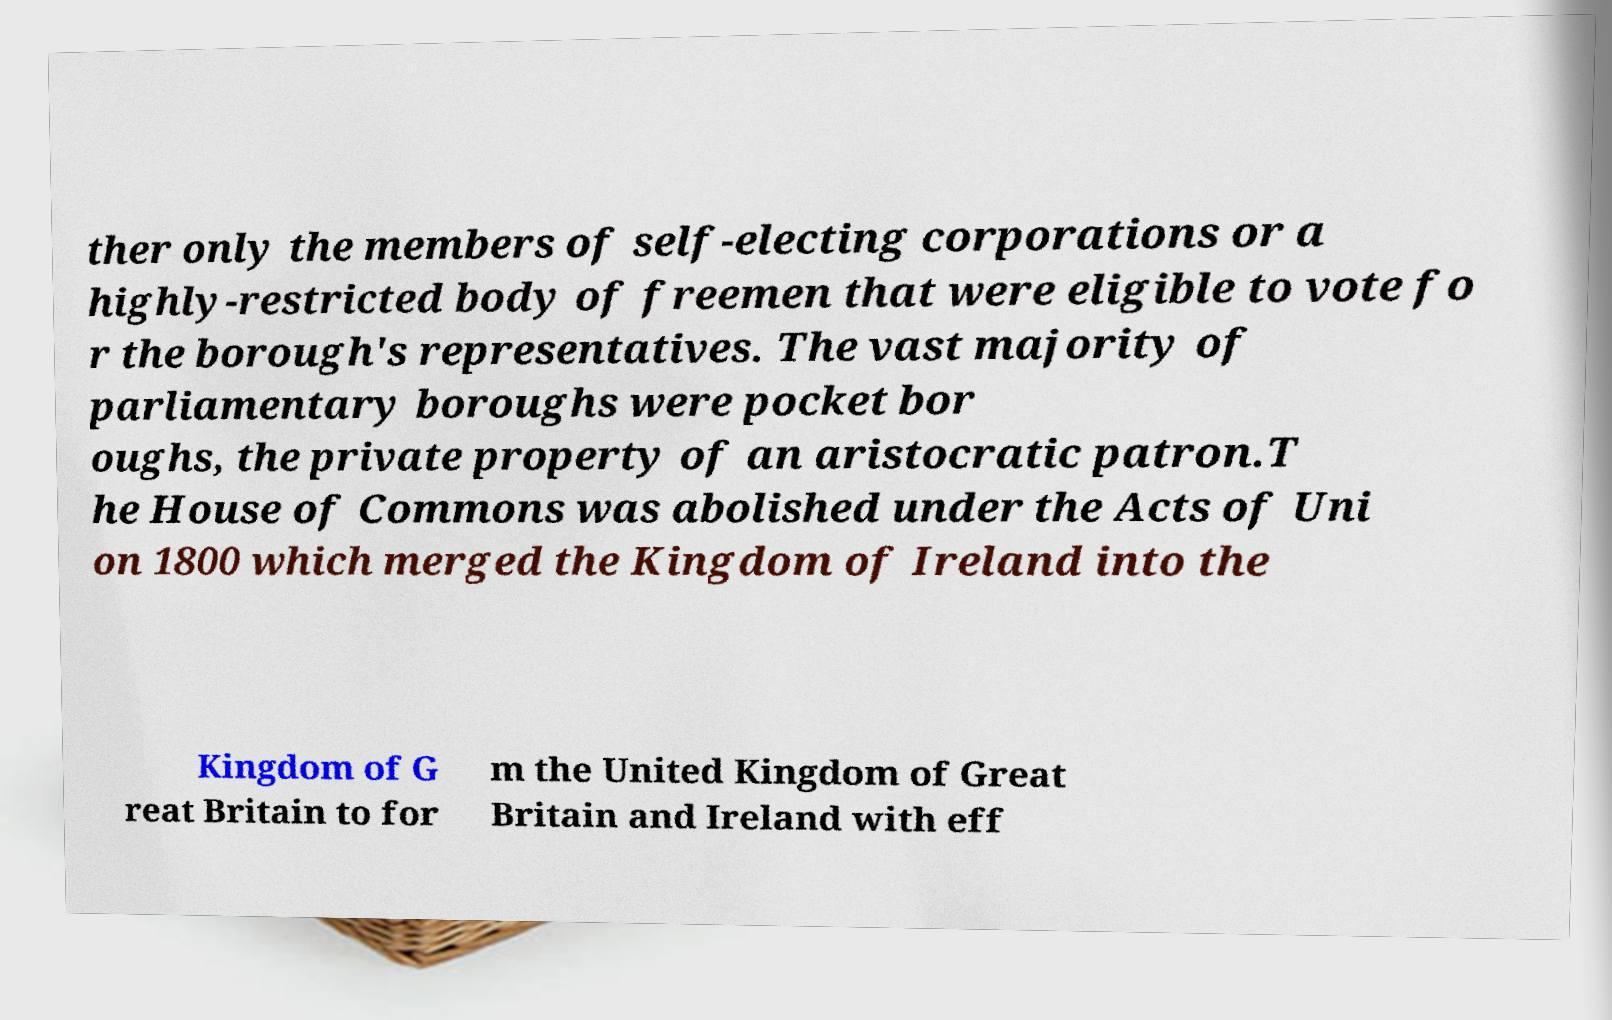Please read and relay the text visible in this image. What does it say? ther only the members of self-electing corporations or a highly-restricted body of freemen that were eligible to vote fo r the borough's representatives. The vast majority of parliamentary boroughs were pocket bor oughs, the private property of an aristocratic patron.T he House of Commons was abolished under the Acts of Uni on 1800 which merged the Kingdom of Ireland into the Kingdom of G reat Britain to for m the United Kingdom of Great Britain and Ireland with eff 